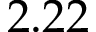Convert formula to latex. <formula><loc_0><loc_0><loc_500><loc_500>2 . 2 2</formula> 